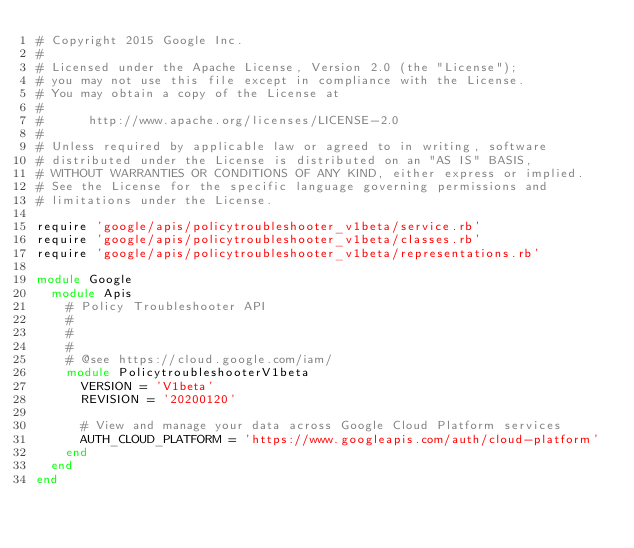<code> <loc_0><loc_0><loc_500><loc_500><_Ruby_># Copyright 2015 Google Inc.
#
# Licensed under the Apache License, Version 2.0 (the "License");
# you may not use this file except in compliance with the License.
# You may obtain a copy of the License at
#
#      http://www.apache.org/licenses/LICENSE-2.0
#
# Unless required by applicable law or agreed to in writing, software
# distributed under the License is distributed on an "AS IS" BASIS,
# WITHOUT WARRANTIES OR CONDITIONS OF ANY KIND, either express or implied.
# See the License for the specific language governing permissions and
# limitations under the License.

require 'google/apis/policytroubleshooter_v1beta/service.rb'
require 'google/apis/policytroubleshooter_v1beta/classes.rb'
require 'google/apis/policytroubleshooter_v1beta/representations.rb'

module Google
  module Apis
    # Policy Troubleshooter API
    #
    # 
    #
    # @see https://cloud.google.com/iam/
    module PolicytroubleshooterV1beta
      VERSION = 'V1beta'
      REVISION = '20200120'

      # View and manage your data across Google Cloud Platform services
      AUTH_CLOUD_PLATFORM = 'https://www.googleapis.com/auth/cloud-platform'
    end
  end
end
</code> 